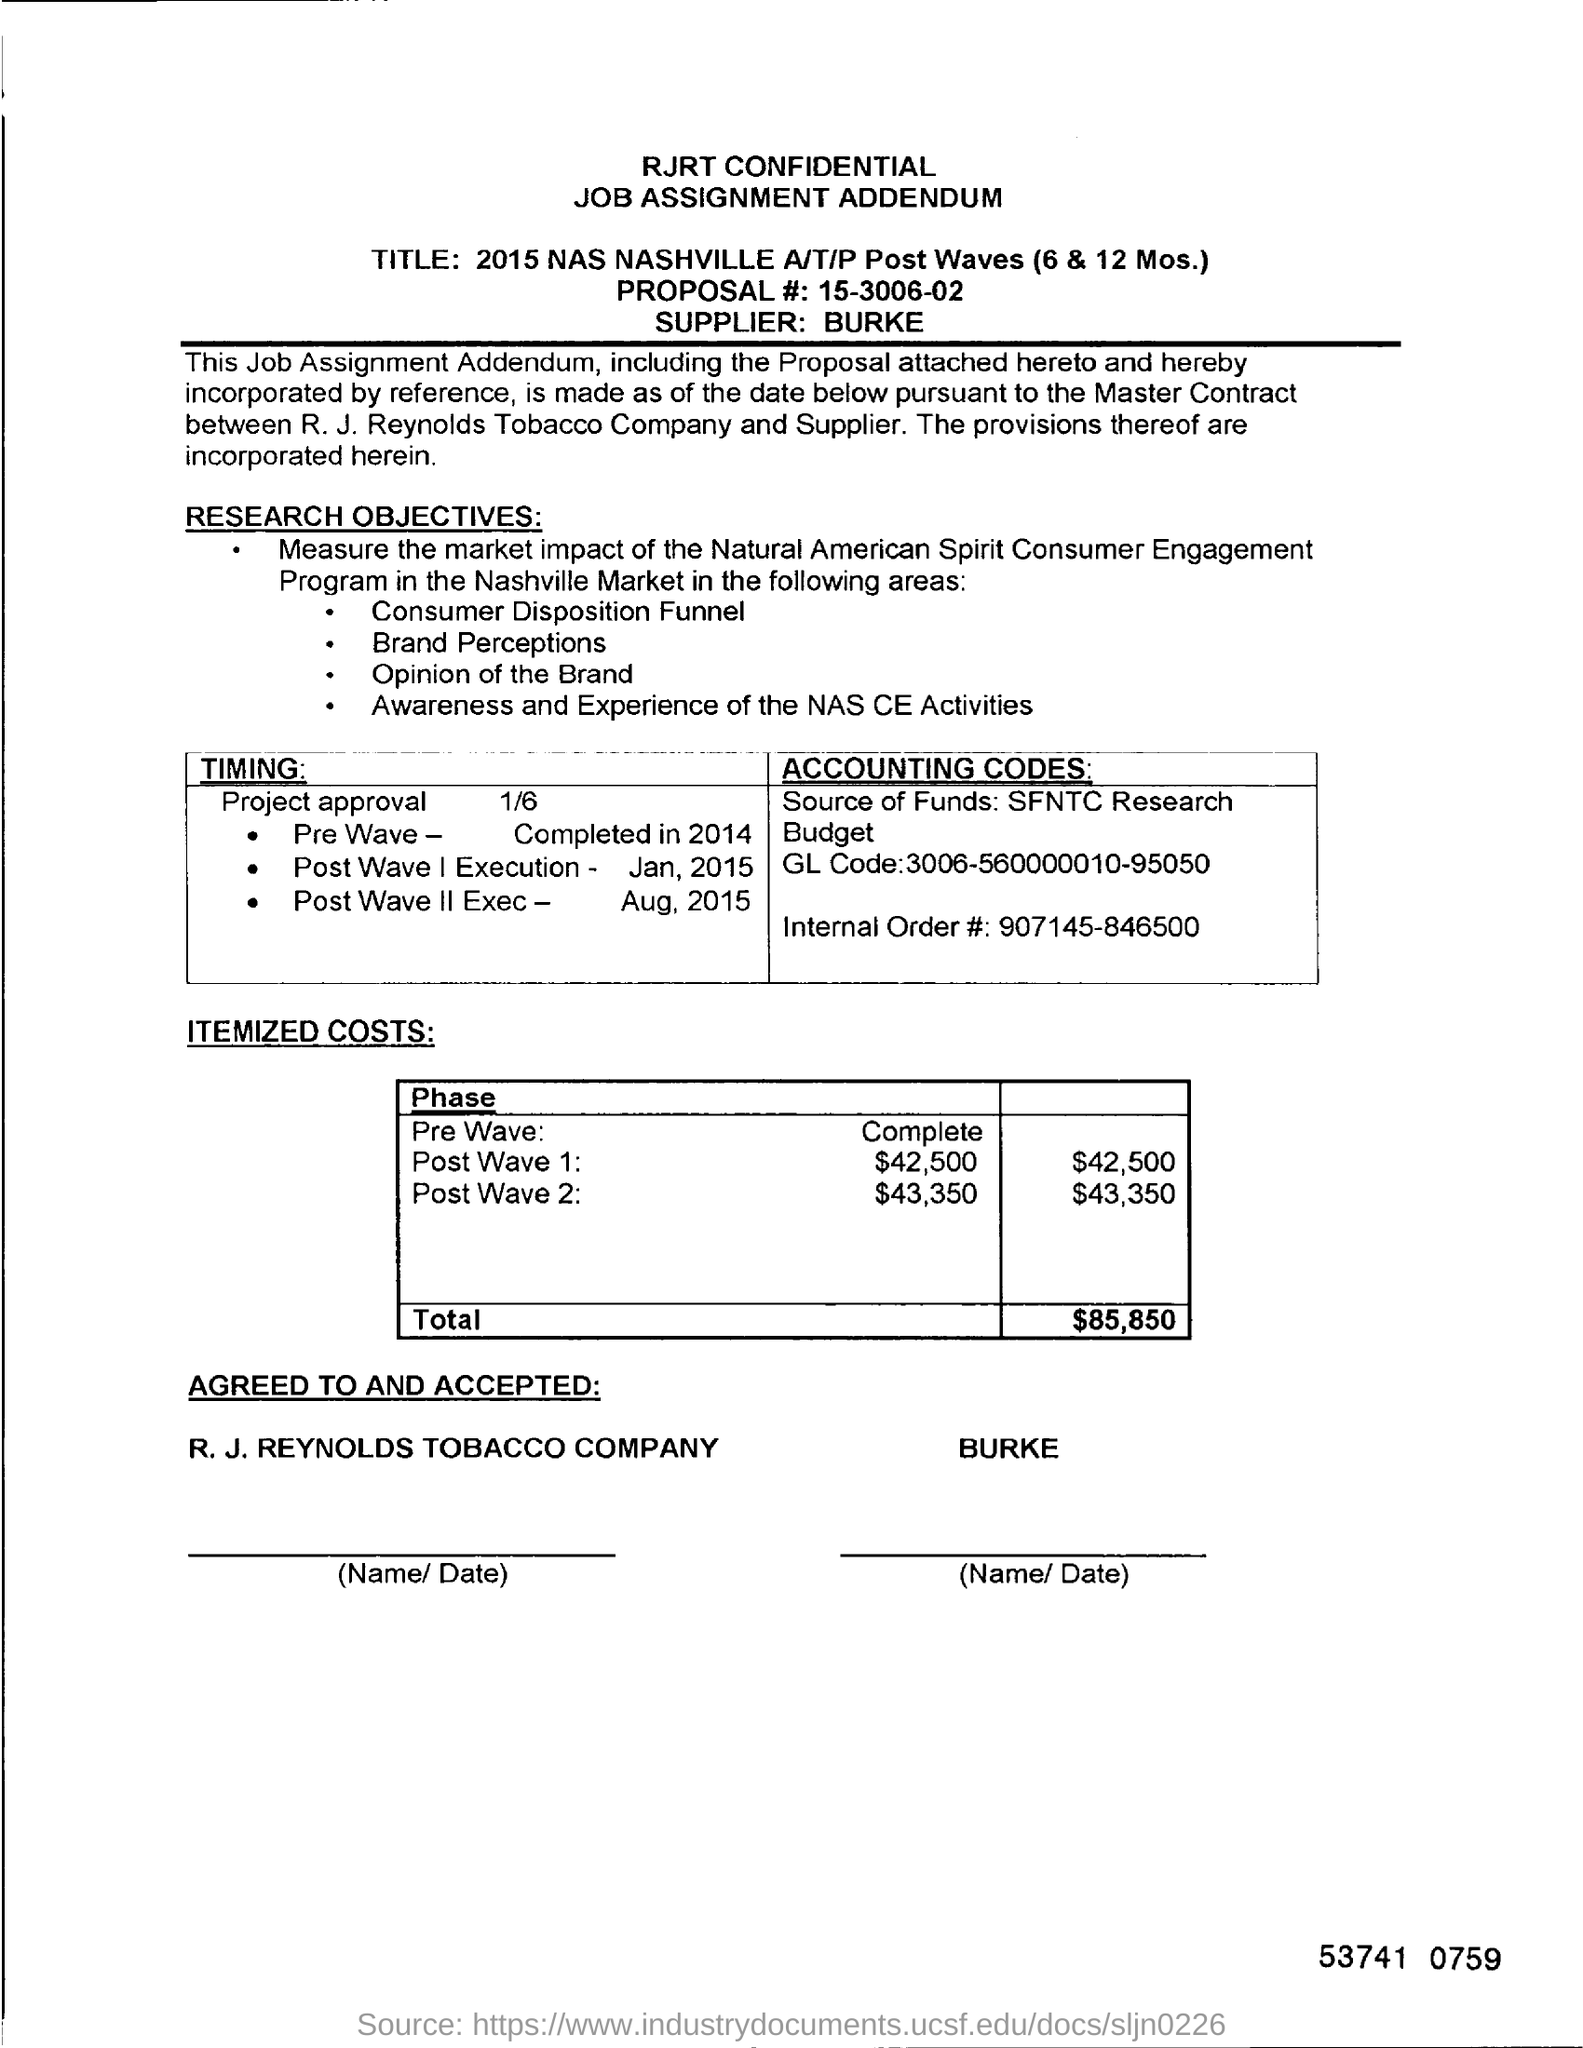Highlight a few significant elements in this photo. The itemized costs for Post Wave 1 are $42,500. The itemized costs total $85,850. The supplier is Burke. 